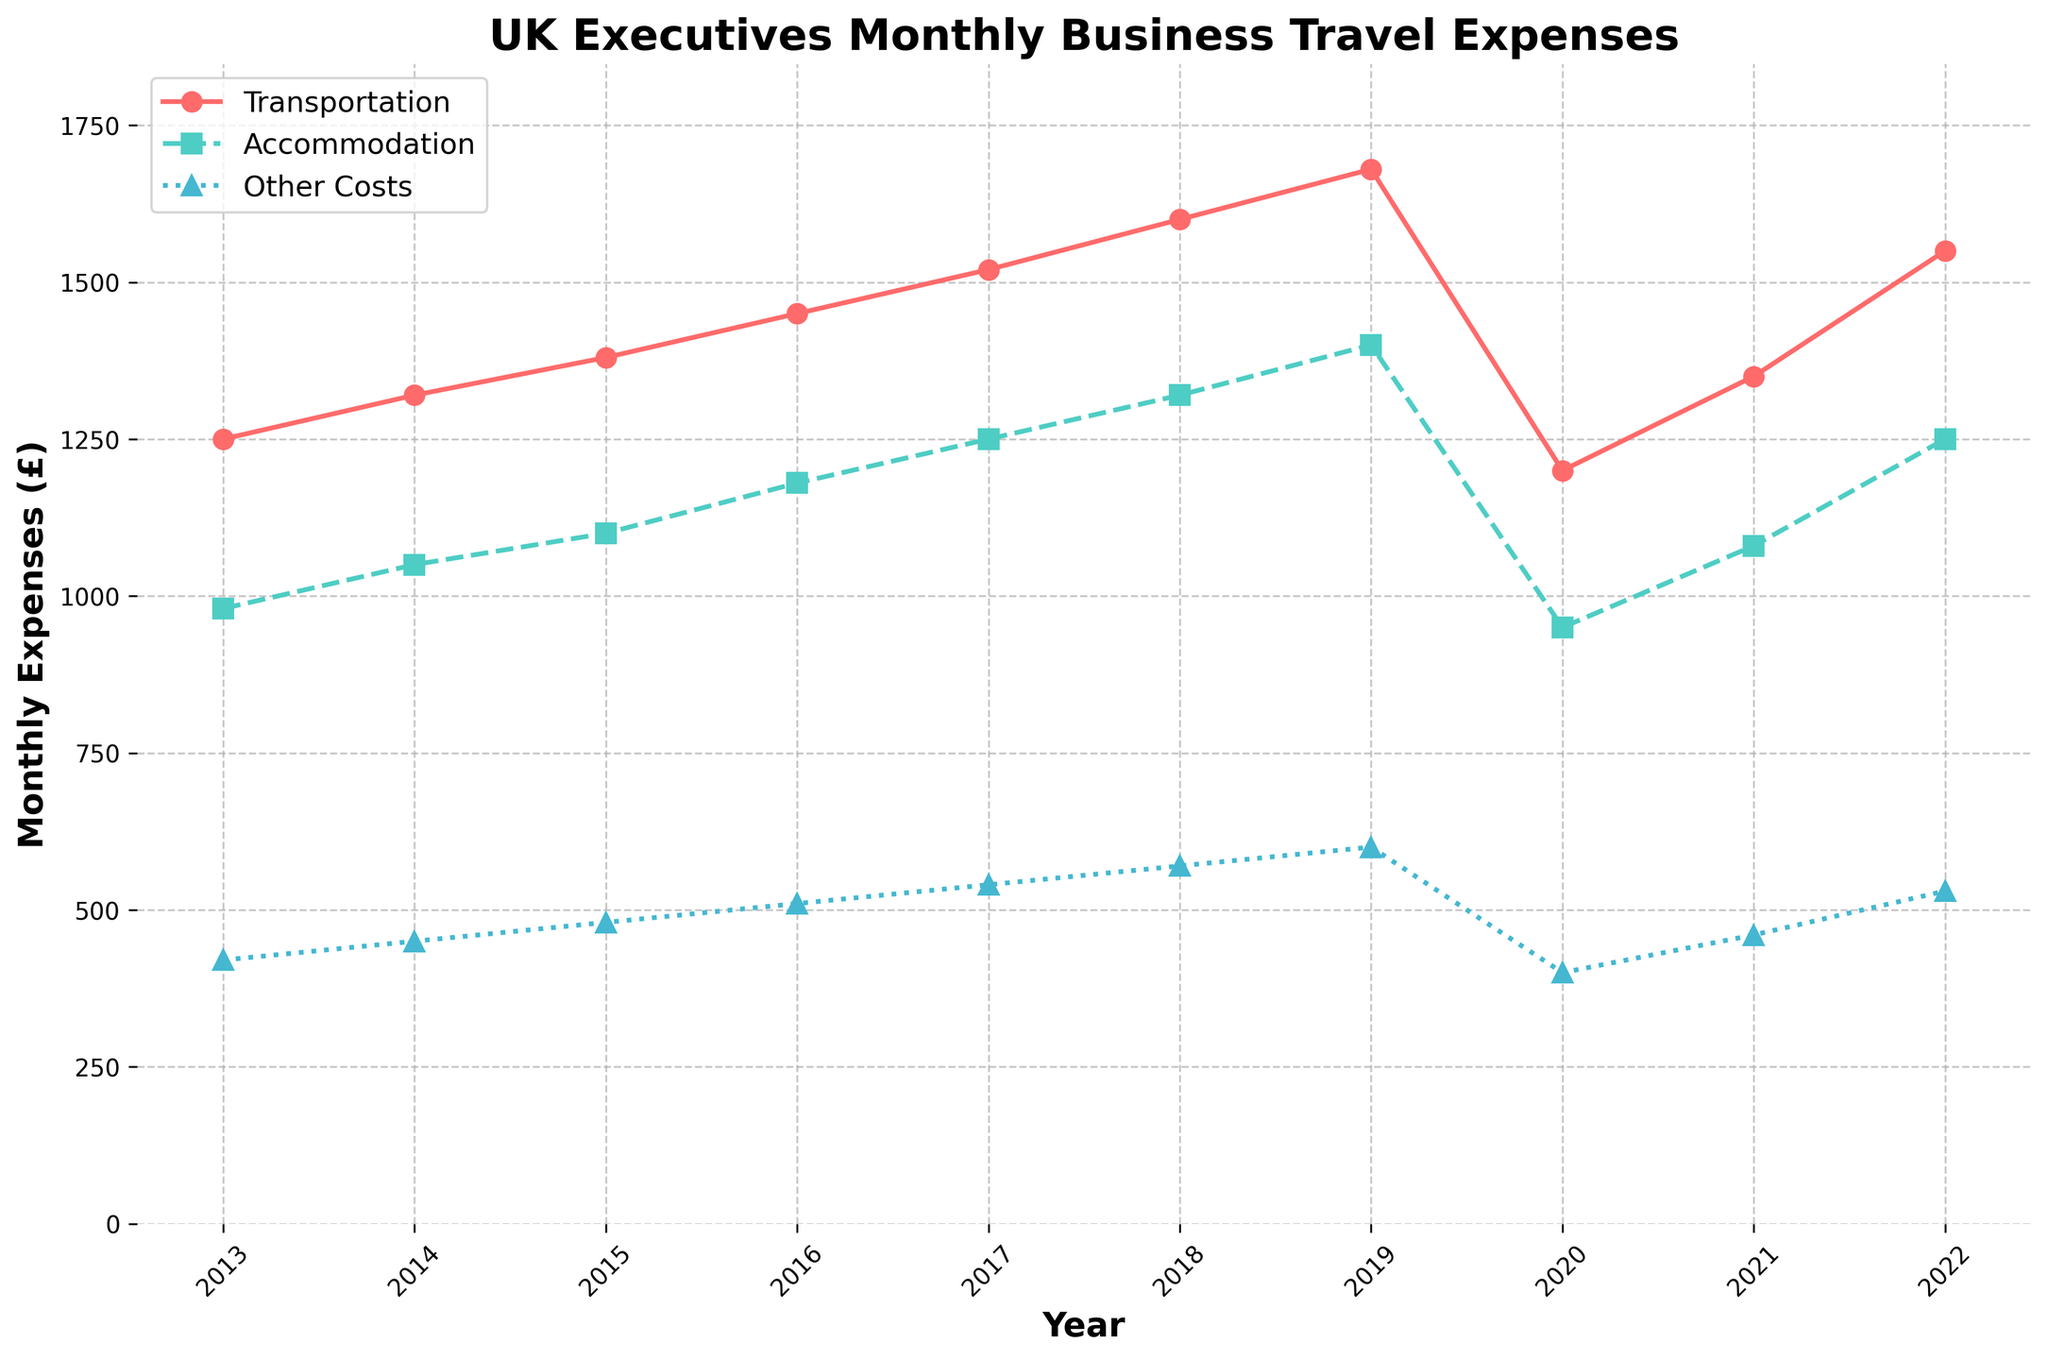What year had the highest transportation expenses? The highest transportation expense can be seen at the highest point on the red line. By comparing the peaks, 2019 is the year with the highest transportation expenses.
Answer: 2019 Is the accommodation cost in 2018 higher than in 2015? To answer this, compare the height of the green line representing accommodation between the years 2018 and 2015. The 2018 mark (1320) is higher than the 2015 mark (1100).
Answer: Yes Which year saw the lowest "Other Costs" expenses? By examining the purple line for its lowest point, 2020 had the lowest "Other Costs" at a value of 400.
Answer: 2020 What is the total transportation cost over the given years? Add the transportation expenses for each year: 1250 + 1320 + 1380 + 1450 + 1520 + 1600 + 1680 + 1200 + 1350 + 1550 = 14300.
Answer: 14300 By how much did the transportation expenses change from 2019 to 2020? Subtract the 2020 expense from the 2019 expense: 1680 - 1200 = 480.
Answer: 480 What are the average monthly accommodation costs for the decade? Sum the accommodation costs and divide by the number of years: (980 + 1050 + 1100 + 1180 + 1250 + 1320 + 1400 + 950 + 1080 + 1250)/10 = 1156.
Answer: 1156 In which years did transportation costs surpass accommodation costs? Identify years when the red line is above the green line: 2013, 2014, 2015, 2016, 2017, 2018, 2019, 2021, 2022.
Answer: 2013, 2014, 2015, 2016, 2017, 2018, 2019, 2021, 2022 How did the "Other Costs" trend change from 2019 to 2020? The "Other Costs" indicated by the purple line shows a decline from 600 in 2019 to 400 in 2020.
Answer: Decreased What is the sum of transportation and accommodation expenses in 2022? Add the transportation and accommodation expenses for 2022: 1550 + 1250 = 2800.
Answer: 2800 Which category experienced the highest growth from 2013 to 2022? Calculate the growth for each category: Transportation: 1550 - 1250 = 300, Accommodation: 1250 - 980 = 270, Other Costs: 530 - 420 = 110. The highest growth is in the transportation category.
Answer: Transportation 